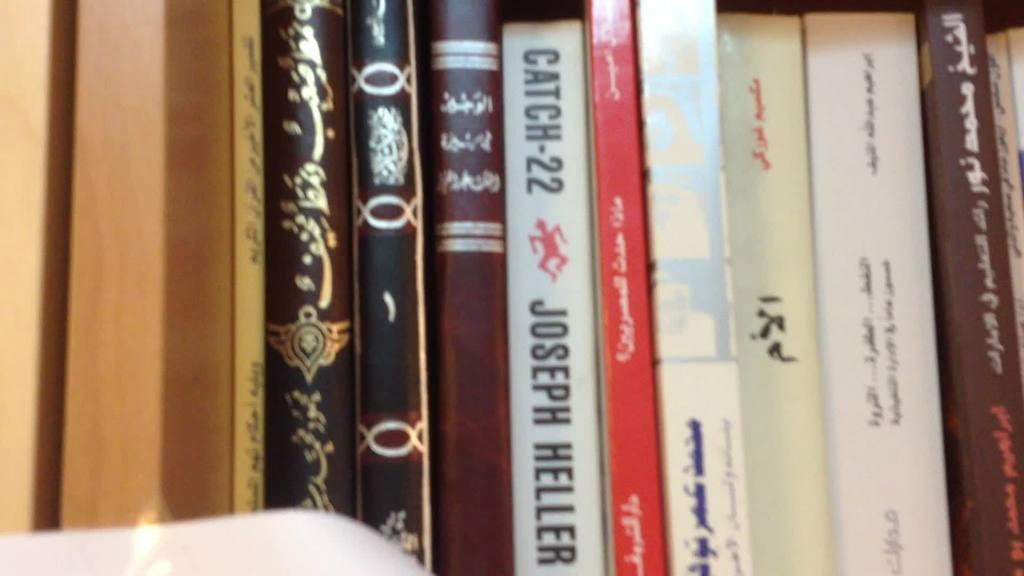Provide a one-sentence caption for the provided image. A book titled, "Catch-22" sits on a shelf next to a red book. 